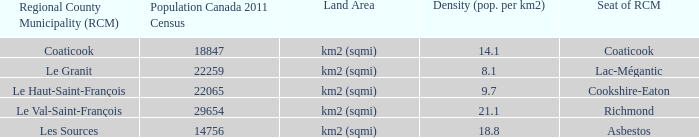What is the position of the rcm in the county featuring a Cookshire-Eaton. 